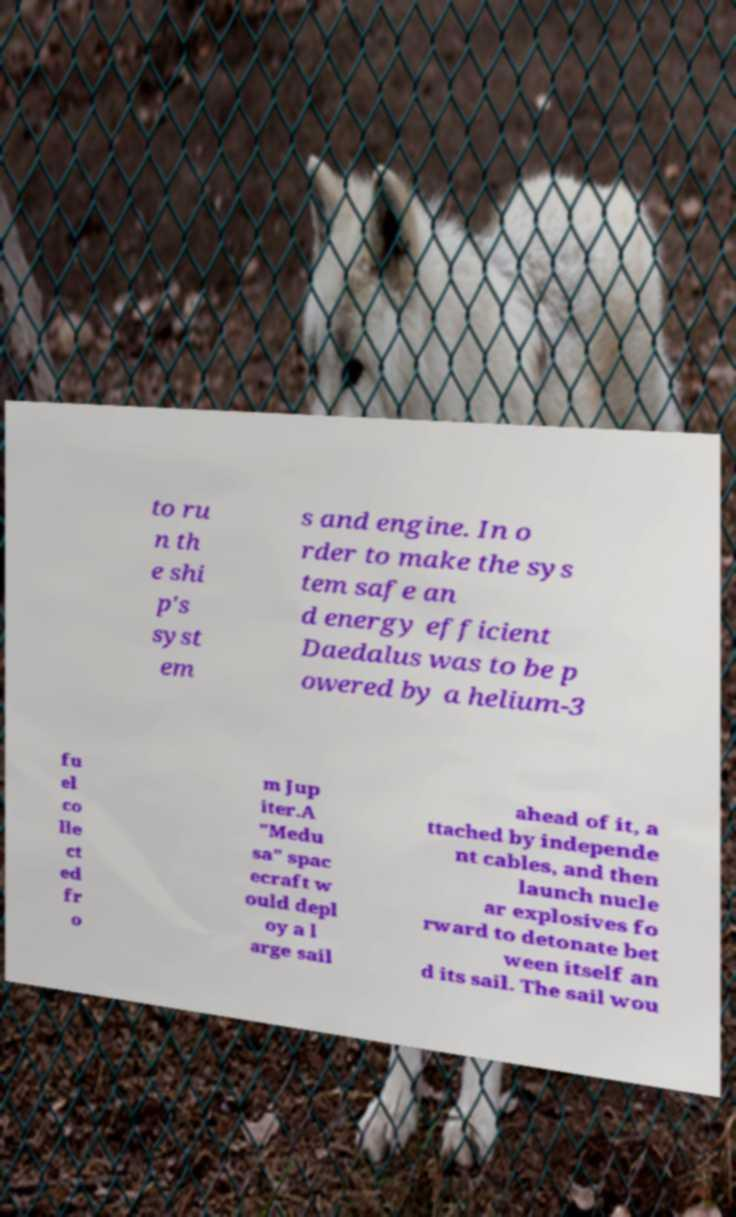Can you accurately transcribe the text from the provided image for me? to ru n th e shi p's syst em s and engine. In o rder to make the sys tem safe an d energy efficient Daedalus was to be p owered by a helium-3 fu el co lle ct ed fr o m Jup iter.A "Medu sa" spac ecraft w ould depl oy a l arge sail ahead of it, a ttached by independe nt cables, and then launch nucle ar explosives fo rward to detonate bet ween itself an d its sail. The sail wou 